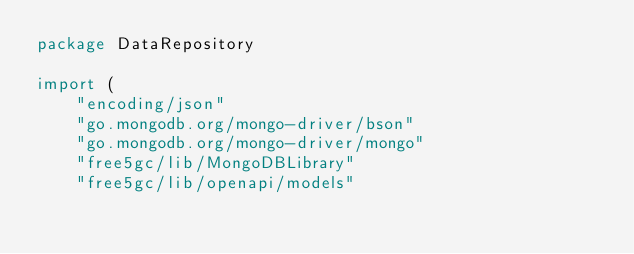Convert code to text. <code><loc_0><loc_0><loc_500><loc_500><_Go_>package DataRepository

import (
	"encoding/json"
	"go.mongodb.org/mongo-driver/bson"
	"go.mongodb.org/mongo-driver/mongo"
	"free5gc/lib/MongoDBLibrary"
	"free5gc/lib/openapi/models"</code> 